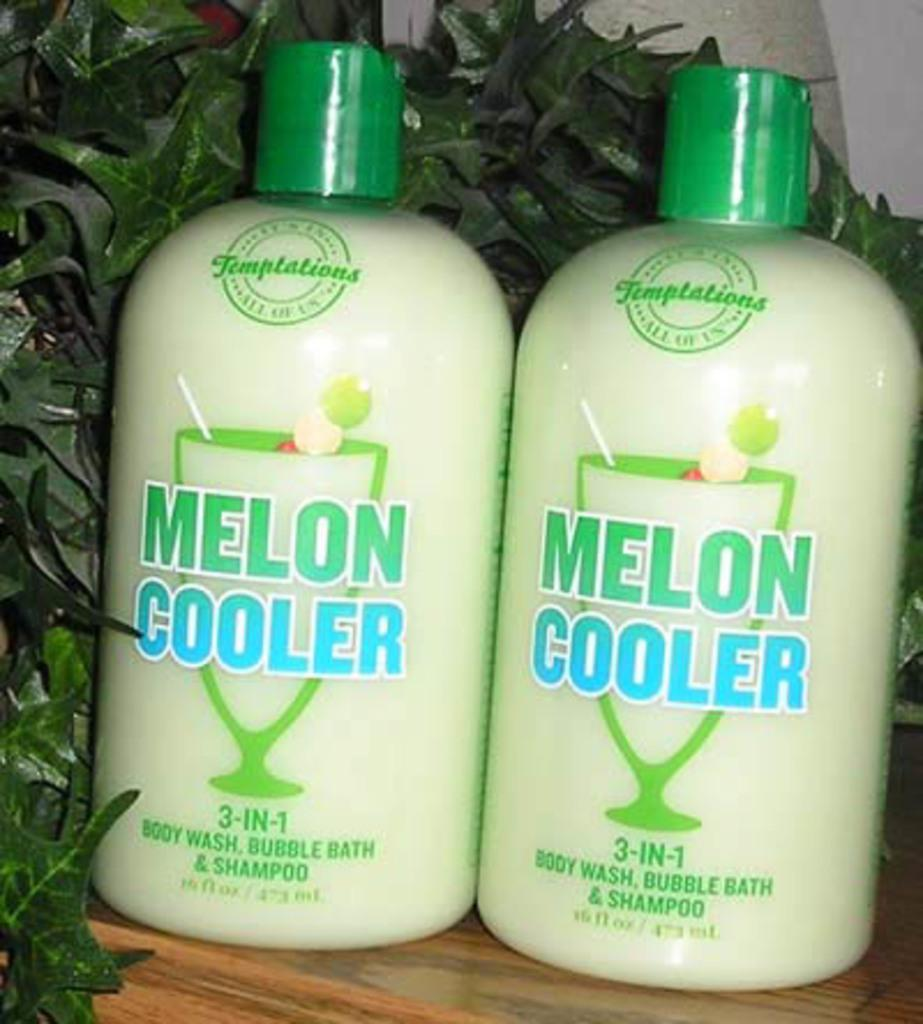What is located in the middle of the image? There is a table in the middle of the image. What can be seen on the table? There are two bottles with caps on the table. What can be observed in the background of the image? Many leaves are visible in the background of the image. What type of bean is growing on the chin of the person in the image? There is no person present in the image, and therefore no chin or bean can be observed. 